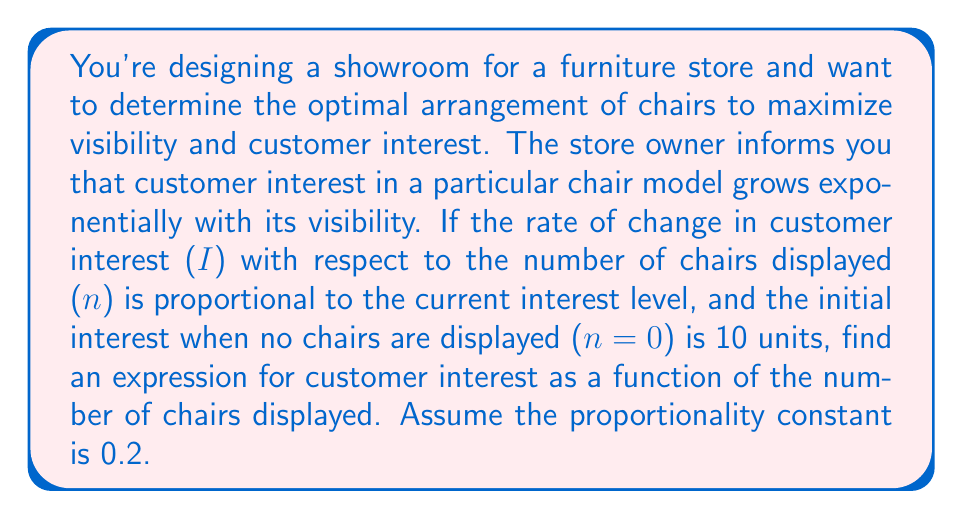Teach me how to tackle this problem. Let's approach this step-by-step using a first-order differential equation:

1) We're told that the rate of change in interest with respect to the number of chairs is proportional to the current interest level. This can be expressed as:

   $$\frac{dI}{dn} = kI$$

   where $k$ is the proportionality constant, given as 0.2.

2) We're also given the initial condition: when $n=0$, $I=10$.

3) This is a separable differential equation. Let's separate the variables:

   $$\frac{dI}{I} = k\,dn$$

4) Integrate both sides:

   $$\int \frac{dI}{I} = \int k\,dn$$

5) This gives us:

   $$\ln|I| = kn + C$$

   where $C$ is the constant of integration.

6) Exponentiate both sides:

   $$I = e^{kn + C} = e^C \cdot e^{kn}$$

7) Let $A = e^C$. Then our general solution is:

   $$I = Ae^{kn}$$

8) Now, use the initial condition to find $A$:
   When $n=0$, $I=10$

   $$10 = Ae^{0.2 \cdot 0} = A$$

9) Therefore, our specific solution is:

   $$I = 10e^{0.2n}$$

This expression gives the customer interest $I$ as a function of the number of chairs displayed $n$.
Answer: $I = 10e^{0.2n}$ 